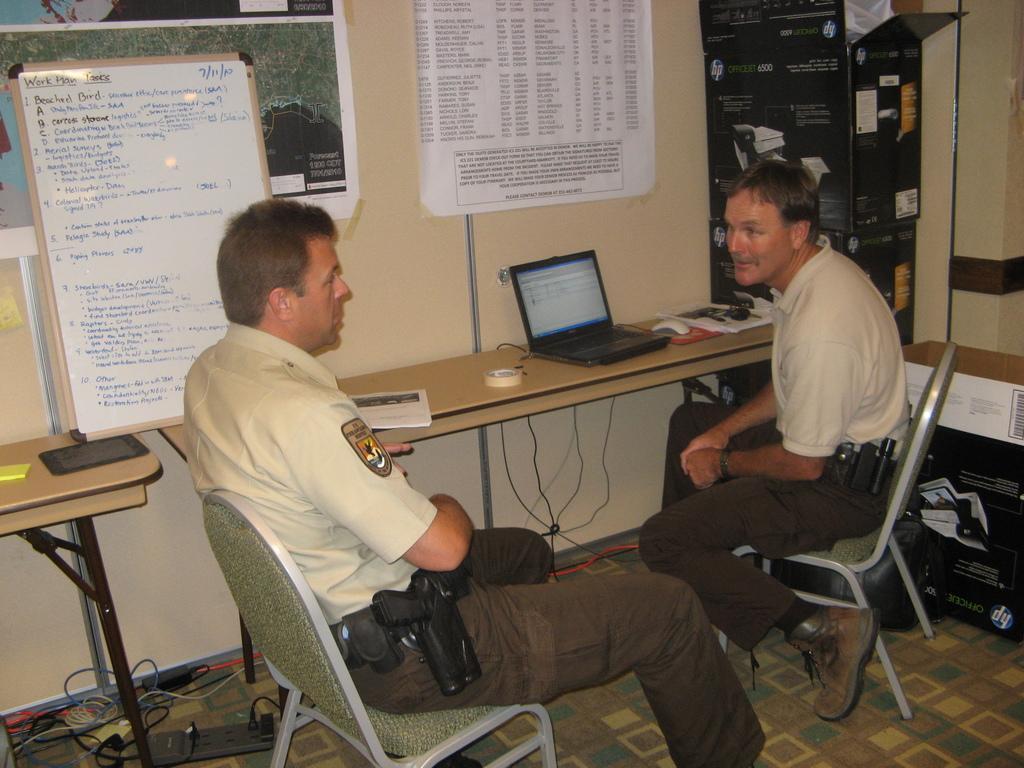Please provide a concise description of this image. In this picture we can see two persons sitting on the chairs. This is table. On the table there is a book, laptop, mouse, and papers. On the background there is a wall. And these are the posters. This is board. Here we can see cables. And this is floor. 